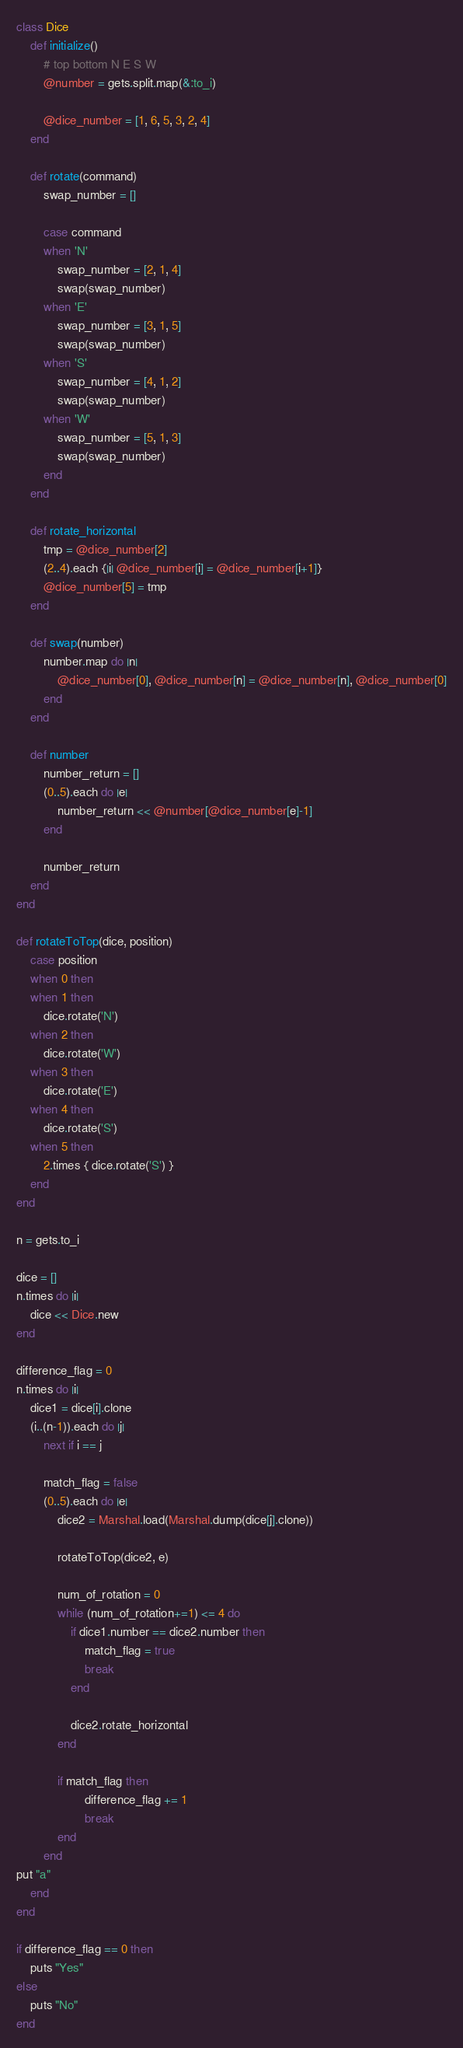<code> <loc_0><loc_0><loc_500><loc_500><_Ruby_>class Dice
	def initialize()
		# top bottom N E S W
		@number = gets.split.map(&:to_i)

		@dice_number = [1, 6, 5, 3, 2, 4]
	end

	def rotate(command)
		swap_number = []

		case command
		when 'N'
			swap_number = [2, 1, 4]
			swap(swap_number)
		when 'E'
			swap_number = [3, 1, 5]
			swap(swap_number)
		when 'S'
			swap_number = [4, 1, 2]
			swap(swap_number)
		when 'W'
			swap_number = [5, 1, 3]
			swap(swap_number)
		end
	end

	def rotate_horizontal
		tmp = @dice_number[2]
		(2..4).each {|i| @dice_number[i] = @dice_number[i+1]}
		@dice_number[5] = tmp
	end

	def swap(number)
		number.map do |n|
			@dice_number[0], @dice_number[n] = @dice_number[n], @dice_number[0]
		end
	end

	def number
		number_return = []
		(0..5).each do |e|
			number_return << @number[@dice_number[e]-1]
		end
		
		number_return
	end
end

def rotateToTop(dice, position)
	case position
	when 0 then
	when 1 then
		dice.rotate('N')
	when 2 then
		dice.rotate('W')
	when 3 then
		dice.rotate('E')
	when 4 then
		dice.rotate('S')
	when 5 then
		2.times { dice.rotate('S') }
	end
end

n = gets.to_i

dice = []
n.times do |i|
	dice << Dice.new
end

difference_flag = 0
n.times do |i|
	dice1 = dice[i].clone
	(i..(n-1)).each do |j|
		next if i == j

		match_flag = false
		(0..5).each do |e|
			dice2 = Marshal.load(Marshal.dump(dice[j].clone))

			rotateToTop(dice2, e)

			num_of_rotation = 0
			while (num_of_rotation+=1) <= 4 do
				if dice1.number == dice2.number then
					match_flag = true
					break
				end
		
				dice2.rotate_horizontal
			end
	
			if match_flag then
					difference_flag += 1
					break
			end
		end
put "a"
	end
end

if difference_flag == 0 then
	puts "Yes"
else
	puts "No"
end</code> 